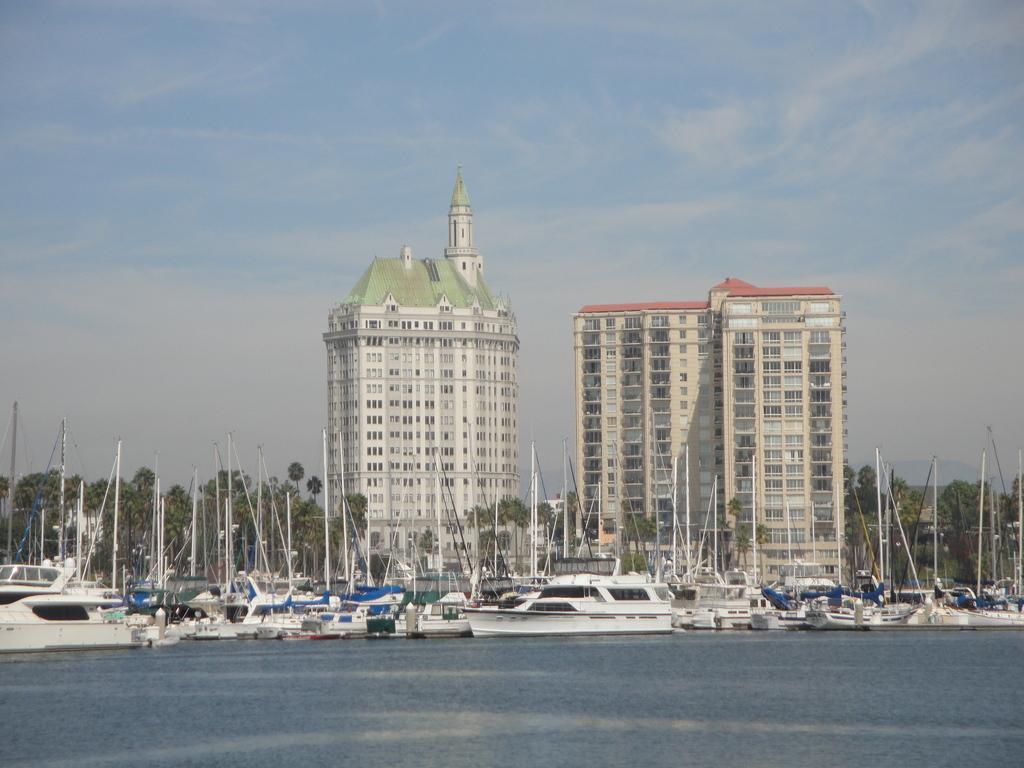Please provide a concise description of this image. In this image I can see few ships which are white in color on the surface of the water. In the background I can see few trees, few buildings and the sky. 